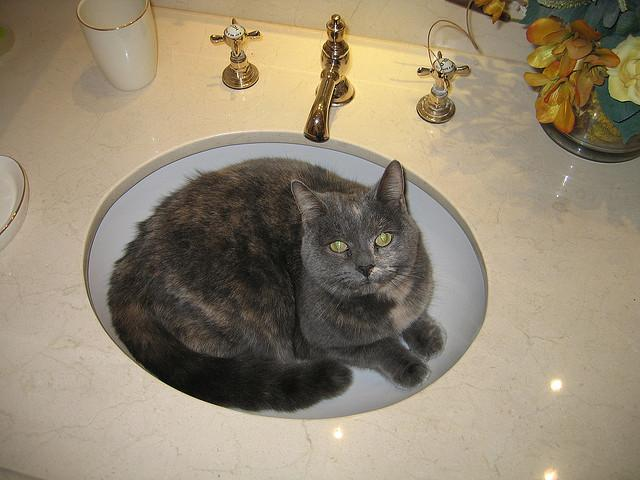Why should this cat be scared? Please explain your reasoning. water. Cat's are known to not enjoy water too much. the cat is under a faucet which function is to provide water and because of cat's dislike of water, it should be scared that the water would start and get on it. 